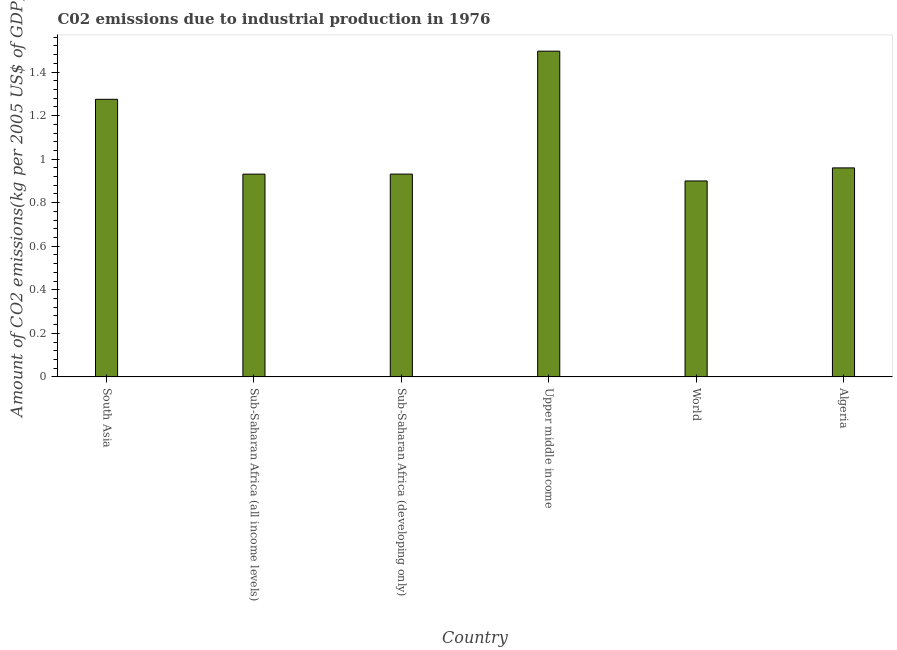Does the graph contain grids?
Offer a terse response. No. What is the title of the graph?
Offer a terse response. C02 emissions due to industrial production in 1976. What is the label or title of the Y-axis?
Your answer should be compact. Amount of CO2 emissions(kg per 2005 US$ of GDP). What is the amount of co2 emissions in South Asia?
Give a very brief answer. 1.27. Across all countries, what is the maximum amount of co2 emissions?
Offer a terse response. 1.5. Across all countries, what is the minimum amount of co2 emissions?
Your response must be concise. 0.9. In which country was the amount of co2 emissions maximum?
Offer a very short reply. Upper middle income. In which country was the amount of co2 emissions minimum?
Your answer should be very brief. World. What is the sum of the amount of co2 emissions?
Provide a short and direct response. 6.49. What is the difference between the amount of co2 emissions in South Asia and Sub-Saharan Africa (all income levels)?
Make the answer very short. 0.34. What is the average amount of co2 emissions per country?
Offer a very short reply. 1.08. What is the median amount of co2 emissions?
Your response must be concise. 0.95. What is the ratio of the amount of co2 emissions in South Asia to that in World?
Ensure brevity in your answer.  1.42. Is the difference between the amount of co2 emissions in Sub-Saharan Africa (all income levels) and Sub-Saharan Africa (developing only) greater than the difference between any two countries?
Your answer should be very brief. No. What is the difference between the highest and the second highest amount of co2 emissions?
Keep it short and to the point. 0.22. What is the difference between the highest and the lowest amount of co2 emissions?
Provide a short and direct response. 0.6. How many bars are there?
Keep it short and to the point. 6. Are all the bars in the graph horizontal?
Give a very brief answer. No. What is the difference between two consecutive major ticks on the Y-axis?
Your answer should be compact. 0.2. Are the values on the major ticks of Y-axis written in scientific E-notation?
Keep it short and to the point. No. What is the Amount of CO2 emissions(kg per 2005 US$ of GDP) in South Asia?
Your answer should be compact. 1.27. What is the Amount of CO2 emissions(kg per 2005 US$ of GDP) of Sub-Saharan Africa (all income levels)?
Your answer should be compact. 0.93. What is the Amount of CO2 emissions(kg per 2005 US$ of GDP) in Sub-Saharan Africa (developing only)?
Your answer should be very brief. 0.93. What is the Amount of CO2 emissions(kg per 2005 US$ of GDP) of Upper middle income?
Your response must be concise. 1.5. What is the Amount of CO2 emissions(kg per 2005 US$ of GDP) of World?
Offer a terse response. 0.9. What is the Amount of CO2 emissions(kg per 2005 US$ of GDP) in Algeria?
Give a very brief answer. 0.96. What is the difference between the Amount of CO2 emissions(kg per 2005 US$ of GDP) in South Asia and Sub-Saharan Africa (all income levels)?
Ensure brevity in your answer.  0.34. What is the difference between the Amount of CO2 emissions(kg per 2005 US$ of GDP) in South Asia and Sub-Saharan Africa (developing only)?
Give a very brief answer. 0.34. What is the difference between the Amount of CO2 emissions(kg per 2005 US$ of GDP) in South Asia and Upper middle income?
Give a very brief answer. -0.22. What is the difference between the Amount of CO2 emissions(kg per 2005 US$ of GDP) in South Asia and World?
Give a very brief answer. 0.38. What is the difference between the Amount of CO2 emissions(kg per 2005 US$ of GDP) in South Asia and Algeria?
Your answer should be compact. 0.32. What is the difference between the Amount of CO2 emissions(kg per 2005 US$ of GDP) in Sub-Saharan Africa (all income levels) and Sub-Saharan Africa (developing only)?
Ensure brevity in your answer.  -0. What is the difference between the Amount of CO2 emissions(kg per 2005 US$ of GDP) in Sub-Saharan Africa (all income levels) and Upper middle income?
Make the answer very short. -0.56. What is the difference between the Amount of CO2 emissions(kg per 2005 US$ of GDP) in Sub-Saharan Africa (all income levels) and World?
Give a very brief answer. 0.03. What is the difference between the Amount of CO2 emissions(kg per 2005 US$ of GDP) in Sub-Saharan Africa (all income levels) and Algeria?
Offer a terse response. -0.03. What is the difference between the Amount of CO2 emissions(kg per 2005 US$ of GDP) in Sub-Saharan Africa (developing only) and Upper middle income?
Make the answer very short. -0.56. What is the difference between the Amount of CO2 emissions(kg per 2005 US$ of GDP) in Sub-Saharan Africa (developing only) and World?
Offer a terse response. 0.03. What is the difference between the Amount of CO2 emissions(kg per 2005 US$ of GDP) in Sub-Saharan Africa (developing only) and Algeria?
Your answer should be very brief. -0.03. What is the difference between the Amount of CO2 emissions(kg per 2005 US$ of GDP) in Upper middle income and World?
Offer a terse response. 0.6. What is the difference between the Amount of CO2 emissions(kg per 2005 US$ of GDP) in Upper middle income and Algeria?
Your answer should be compact. 0.54. What is the difference between the Amount of CO2 emissions(kg per 2005 US$ of GDP) in World and Algeria?
Make the answer very short. -0.06. What is the ratio of the Amount of CO2 emissions(kg per 2005 US$ of GDP) in South Asia to that in Sub-Saharan Africa (all income levels)?
Provide a short and direct response. 1.37. What is the ratio of the Amount of CO2 emissions(kg per 2005 US$ of GDP) in South Asia to that in Sub-Saharan Africa (developing only)?
Make the answer very short. 1.37. What is the ratio of the Amount of CO2 emissions(kg per 2005 US$ of GDP) in South Asia to that in Upper middle income?
Your response must be concise. 0.85. What is the ratio of the Amount of CO2 emissions(kg per 2005 US$ of GDP) in South Asia to that in World?
Your answer should be very brief. 1.42. What is the ratio of the Amount of CO2 emissions(kg per 2005 US$ of GDP) in South Asia to that in Algeria?
Offer a very short reply. 1.33. What is the ratio of the Amount of CO2 emissions(kg per 2005 US$ of GDP) in Sub-Saharan Africa (all income levels) to that in Upper middle income?
Provide a succinct answer. 0.62. What is the ratio of the Amount of CO2 emissions(kg per 2005 US$ of GDP) in Sub-Saharan Africa (all income levels) to that in World?
Give a very brief answer. 1.03. What is the ratio of the Amount of CO2 emissions(kg per 2005 US$ of GDP) in Sub-Saharan Africa (all income levels) to that in Algeria?
Your answer should be compact. 0.97. What is the ratio of the Amount of CO2 emissions(kg per 2005 US$ of GDP) in Sub-Saharan Africa (developing only) to that in Upper middle income?
Your answer should be very brief. 0.62. What is the ratio of the Amount of CO2 emissions(kg per 2005 US$ of GDP) in Sub-Saharan Africa (developing only) to that in World?
Offer a very short reply. 1.03. What is the ratio of the Amount of CO2 emissions(kg per 2005 US$ of GDP) in Upper middle income to that in World?
Give a very brief answer. 1.66. What is the ratio of the Amount of CO2 emissions(kg per 2005 US$ of GDP) in Upper middle income to that in Algeria?
Your response must be concise. 1.56. What is the ratio of the Amount of CO2 emissions(kg per 2005 US$ of GDP) in World to that in Algeria?
Ensure brevity in your answer.  0.94. 